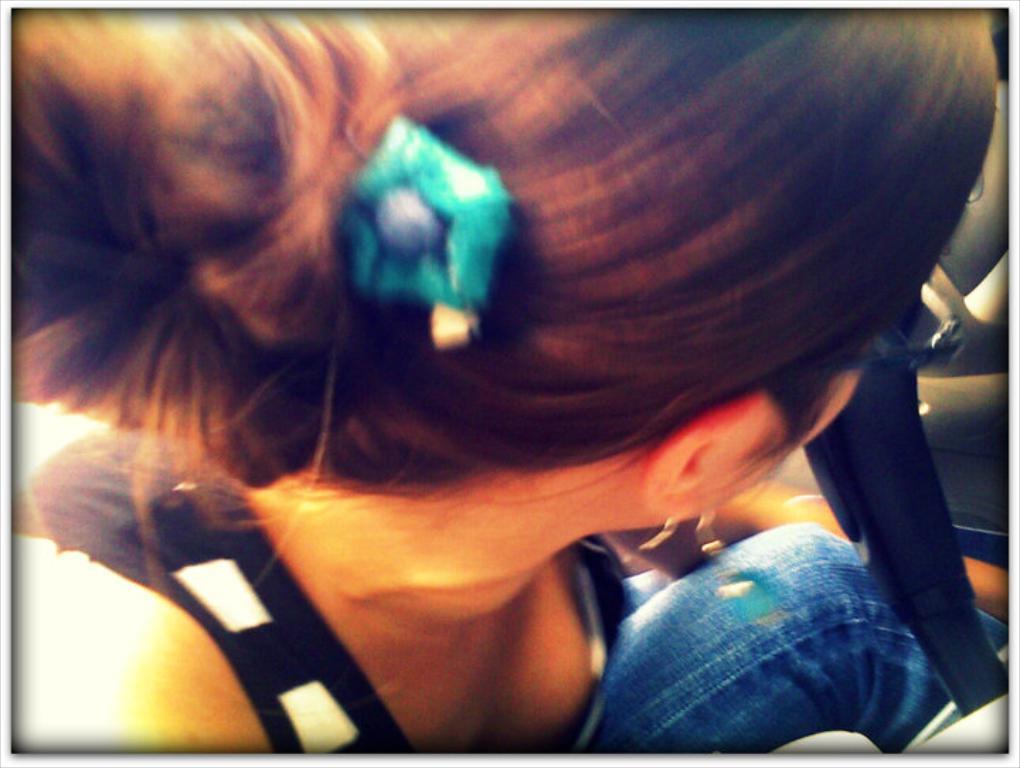How would you summarize this image in a sentence or two? In this image we can see a lady sitting. 